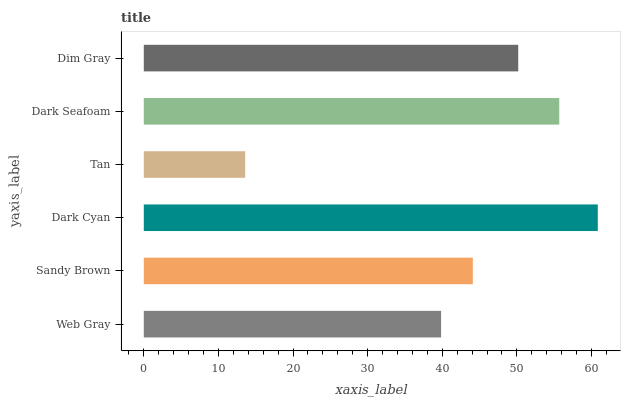Is Tan the minimum?
Answer yes or no. Yes. Is Dark Cyan the maximum?
Answer yes or no. Yes. Is Sandy Brown the minimum?
Answer yes or no. No. Is Sandy Brown the maximum?
Answer yes or no. No. Is Sandy Brown greater than Web Gray?
Answer yes or no. Yes. Is Web Gray less than Sandy Brown?
Answer yes or no. Yes. Is Web Gray greater than Sandy Brown?
Answer yes or no. No. Is Sandy Brown less than Web Gray?
Answer yes or no. No. Is Dim Gray the high median?
Answer yes or no. Yes. Is Sandy Brown the low median?
Answer yes or no. Yes. Is Dark Cyan the high median?
Answer yes or no. No. Is Web Gray the low median?
Answer yes or no. No. 